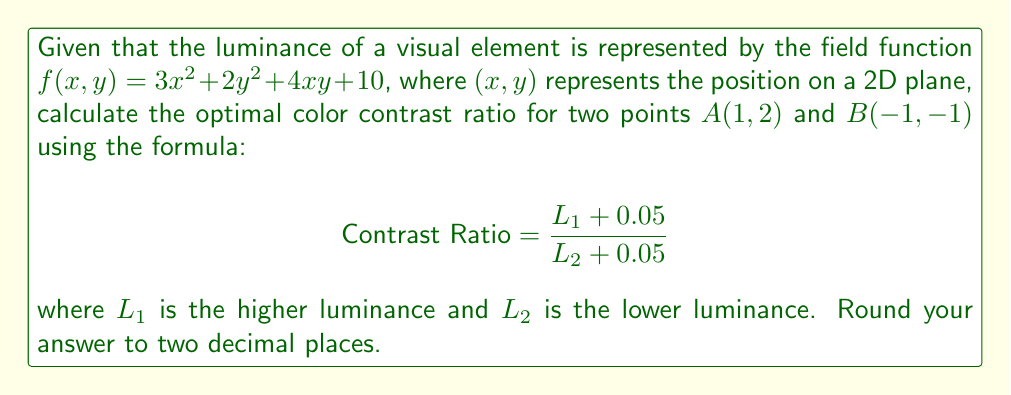Give your solution to this math problem. 1. Calculate the luminance at point A(1,2):
   $f(1,2) = 3(1)^2 + 2(2)^2 + 4(1)(2) + 10$
   $f(1,2) = 3 + 8 + 8 + 10 = 29$
   $L_A = 29$

2. Calculate the luminance at point B(-1,-1):
   $f(-1,-1) = 3(-1)^2 + 2(-1)^2 + 4(-1)(-1) + 10$
   $f(-1,-1) = 3 + 2 + 4 + 10 = 19$
   $L_B = 19$

3. Identify the higher and lower luminance:
   $L_1 = 29$ (point A)
   $L_2 = 19$ (point B)

4. Apply the contrast ratio formula:
   $$\text{Contrast Ratio} = \frac{L_1 + 0.05}{L_2 + 0.05}$$
   $$\text{Contrast Ratio} = \frac{29 + 0.05}{19 + 0.05}$$
   $$\text{Contrast Ratio} = \frac{29.05}{19.05}$$
   $$\text{Contrast Ratio} \approx 1.5249$$

5. Round to two decimal places:
   Optimal Contrast Ratio = 1.52
Answer: 1.52 